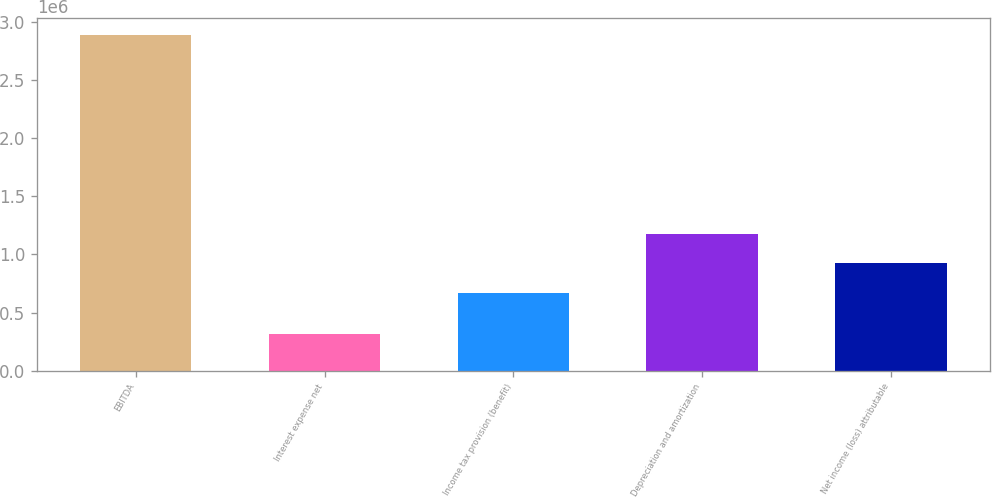<chart> <loc_0><loc_0><loc_500><loc_500><bar_chart><fcel>EBITDA<fcel>Interest expense net<fcel>Income tax provision (benefit)<fcel>Depreciation and amortization<fcel>Net income (loss) attributable<nl><fcel>2.8877e+06<fcel>318661<fcel>665859<fcel>1.17967e+06<fcel>922763<nl></chart> 